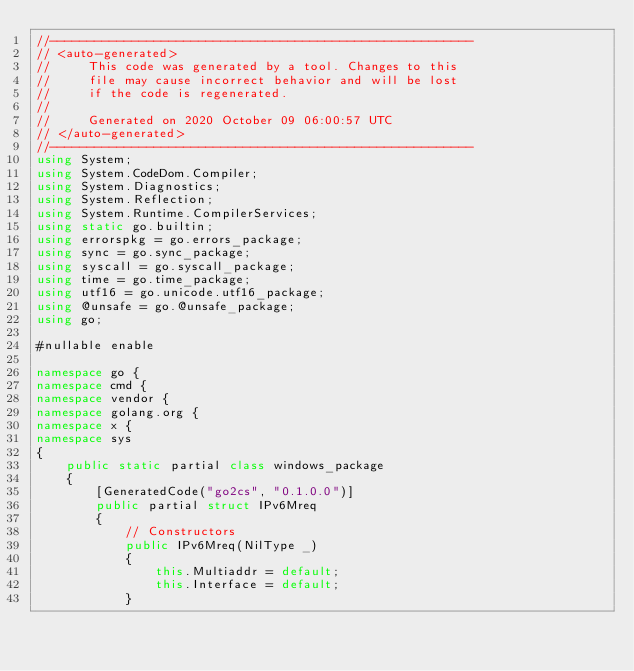Convert code to text. <code><loc_0><loc_0><loc_500><loc_500><_C#_>//---------------------------------------------------------
// <auto-generated>
//     This code was generated by a tool. Changes to this
//     file may cause incorrect behavior and will be lost
//     if the code is regenerated.
//
//     Generated on 2020 October 09 06:00:57 UTC
// </auto-generated>
//---------------------------------------------------------
using System;
using System.CodeDom.Compiler;
using System.Diagnostics;
using System.Reflection;
using System.Runtime.CompilerServices;
using static go.builtin;
using errorspkg = go.errors_package;
using sync = go.sync_package;
using syscall = go.syscall_package;
using time = go.time_package;
using utf16 = go.unicode.utf16_package;
using @unsafe = go.@unsafe_package;
using go;

#nullable enable

namespace go {
namespace cmd {
namespace vendor {
namespace golang.org {
namespace x {
namespace sys
{
    public static partial class windows_package
    {
        [GeneratedCode("go2cs", "0.1.0.0")]
        public partial struct IPv6Mreq
        {
            // Constructors
            public IPv6Mreq(NilType _)
            {
                this.Multiaddr = default;
                this.Interface = default;
            }
</code> 